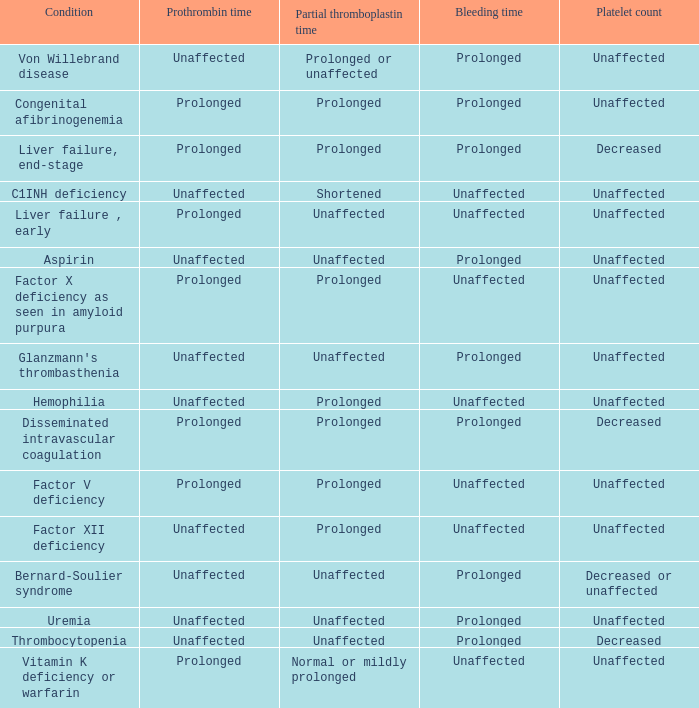Which Platelet count has a Condition of bernard-soulier syndrome? Decreased or unaffected. 